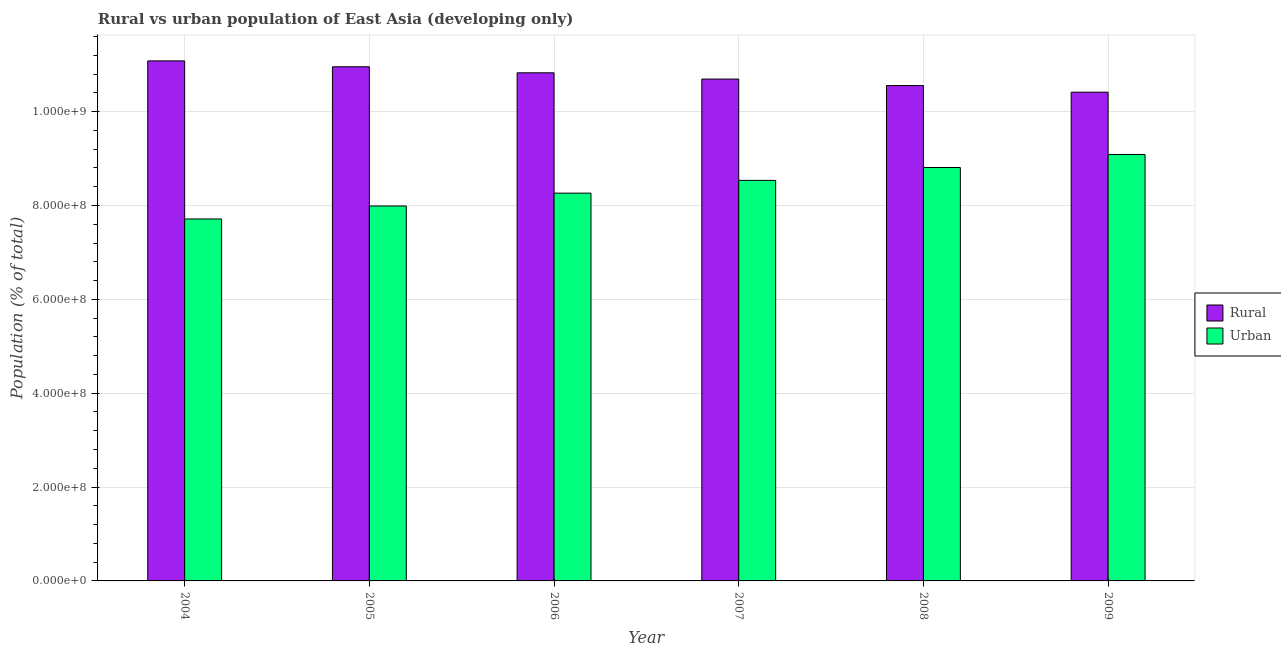How many different coloured bars are there?
Keep it short and to the point. 2. Are the number of bars on each tick of the X-axis equal?
Offer a terse response. Yes. How many bars are there on the 5th tick from the right?
Provide a short and direct response. 2. What is the label of the 6th group of bars from the left?
Offer a very short reply. 2009. In how many cases, is the number of bars for a given year not equal to the number of legend labels?
Keep it short and to the point. 0. What is the urban population density in 2008?
Offer a terse response. 8.81e+08. Across all years, what is the maximum urban population density?
Provide a succinct answer. 9.09e+08. Across all years, what is the minimum urban population density?
Your response must be concise. 7.71e+08. What is the total urban population density in the graph?
Provide a succinct answer. 5.04e+09. What is the difference between the urban population density in 2004 and that in 2006?
Offer a very short reply. -5.51e+07. What is the difference between the urban population density in 2006 and the rural population density in 2009?
Provide a short and direct response. -8.23e+07. What is the average urban population density per year?
Give a very brief answer. 8.40e+08. In the year 2009, what is the difference between the urban population density and rural population density?
Your response must be concise. 0. In how many years, is the rural population density greater than 1040000000 %?
Make the answer very short. 6. What is the ratio of the rural population density in 2005 to that in 2008?
Offer a terse response. 1.04. Is the difference between the rural population density in 2004 and 2005 greater than the difference between the urban population density in 2004 and 2005?
Make the answer very short. No. What is the difference between the highest and the second highest urban population density?
Your answer should be compact. 2.77e+07. What is the difference between the highest and the lowest urban population density?
Give a very brief answer. 1.37e+08. Is the sum of the urban population density in 2004 and 2009 greater than the maximum rural population density across all years?
Ensure brevity in your answer.  Yes. What does the 2nd bar from the left in 2006 represents?
Your answer should be compact. Urban. What does the 1st bar from the right in 2007 represents?
Offer a terse response. Urban. Are all the bars in the graph horizontal?
Your response must be concise. No. Are the values on the major ticks of Y-axis written in scientific E-notation?
Offer a terse response. Yes. What is the title of the graph?
Offer a very short reply. Rural vs urban population of East Asia (developing only). What is the label or title of the X-axis?
Provide a succinct answer. Year. What is the label or title of the Y-axis?
Your response must be concise. Population (% of total). What is the Population (% of total) in Rural in 2004?
Ensure brevity in your answer.  1.11e+09. What is the Population (% of total) of Urban in 2004?
Provide a succinct answer. 7.71e+08. What is the Population (% of total) in Rural in 2005?
Ensure brevity in your answer.  1.10e+09. What is the Population (% of total) in Urban in 2005?
Ensure brevity in your answer.  7.99e+08. What is the Population (% of total) in Rural in 2006?
Your answer should be very brief. 1.08e+09. What is the Population (% of total) in Urban in 2006?
Your answer should be compact. 8.26e+08. What is the Population (% of total) in Rural in 2007?
Keep it short and to the point. 1.07e+09. What is the Population (% of total) in Urban in 2007?
Give a very brief answer. 8.54e+08. What is the Population (% of total) of Rural in 2008?
Give a very brief answer. 1.06e+09. What is the Population (% of total) of Urban in 2008?
Provide a succinct answer. 8.81e+08. What is the Population (% of total) of Rural in 2009?
Ensure brevity in your answer.  1.04e+09. What is the Population (% of total) in Urban in 2009?
Offer a terse response. 9.09e+08. Across all years, what is the maximum Population (% of total) of Rural?
Your answer should be very brief. 1.11e+09. Across all years, what is the maximum Population (% of total) of Urban?
Make the answer very short. 9.09e+08. Across all years, what is the minimum Population (% of total) in Rural?
Your answer should be compact. 1.04e+09. Across all years, what is the minimum Population (% of total) of Urban?
Your response must be concise. 7.71e+08. What is the total Population (% of total) of Rural in the graph?
Your answer should be very brief. 6.45e+09. What is the total Population (% of total) in Urban in the graph?
Keep it short and to the point. 5.04e+09. What is the difference between the Population (% of total) in Rural in 2004 and that in 2005?
Ensure brevity in your answer.  1.26e+07. What is the difference between the Population (% of total) of Urban in 2004 and that in 2005?
Make the answer very short. -2.77e+07. What is the difference between the Population (% of total) of Rural in 2004 and that in 2006?
Offer a terse response. 2.54e+07. What is the difference between the Population (% of total) in Urban in 2004 and that in 2006?
Give a very brief answer. -5.51e+07. What is the difference between the Population (% of total) of Rural in 2004 and that in 2007?
Your answer should be compact. 3.87e+07. What is the difference between the Population (% of total) of Urban in 2004 and that in 2007?
Ensure brevity in your answer.  -8.22e+07. What is the difference between the Population (% of total) in Rural in 2004 and that in 2008?
Make the answer very short. 5.26e+07. What is the difference between the Population (% of total) in Urban in 2004 and that in 2008?
Keep it short and to the point. -1.10e+08. What is the difference between the Population (% of total) of Rural in 2004 and that in 2009?
Offer a very short reply. 6.67e+07. What is the difference between the Population (% of total) in Urban in 2004 and that in 2009?
Provide a short and direct response. -1.37e+08. What is the difference between the Population (% of total) in Rural in 2005 and that in 2006?
Ensure brevity in your answer.  1.28e+07. What is the difference between the Population (% of total) in Urban in 2005 and that in 2006?
Your answer should be very brief. -2.73e+07. What is the difference between the Population (% of total) in Rural in 2005 and that in 2007?
Ensure brevity in your answer.  2.62e+07. What is the difference between the Population (% of total) in Urban in 2005 and that in 2007?
Your answer should be very brief. -5.45e+07. What is the difference between the Population (% of total) in Rural in 2005 and that in 2008?
Offer a terse response. 4.00e+07. What is the difference between the Population (% of total) of Urban in 2005 and that in 2008?
Your answer should be very brief. -8.20e+07. What is the difference between the Population (% of total) of Rural in 2005 and that in 2009?
Provide a short and direct response. 5.42e+07. What is the difference between the Population (% of total) of Urban in 2005 and that in 2009?
Provide a succinct answer. -1.10e+08. What is the difference between the Population (% of total) in Rural in 2006 and that in 2007?
Ensure brevity in your answer.  1.33e+07. What is the difference between the Population (% of total) of Urban in 2006 and that in 2007?
Your answer should be very brief. -2.72e+07. What is the difference between the Population (% of total) in Rural in 2006 and that in 2008?
Provide a short and direct response. 2.72e+07. What is the difference between the Population (% of total) of Urban in 2006 and that in 2008?
Keep it short and to the point. -5.46e+07. What is the difference between the Population (% of total) of Rural in 2006 and that in 2009?
Your answer should be compact. 4.13e+07. What is the difference between the Population (% of total) of Urban in 2006 and that in 2009?
Offer a very short reply. -8.23e+07. What is the difference between the Population (% of total) in Rural in 2007 and that in 2008?
Offer a terse response. 1.38e+07. What is the difference between the Population (% of total) of Urban in 2007 and that in 2008?
Your answer should be very brief. -2.75e+07. What is the difference between the Population (% of total) in Rural in 2007 and that in 2009?
Keep it short and to the point. 2.80e+07. What is the difference between the Population (% of total) of Urban in 2007 and that in 2009?
Ensure brevity in your answer.  -5.52e+07. What is the difference between the Population (% of total) in Rural in 2008 and that in 2009?
Provide a succinct answer. 1.42e+07. What is the difference between the Population (% of total) in Urban in 2008 and that in 2009?
Keep it short and to the point. -2.77e+07. What is the difference between the Population (% of total) of Rural in 2004 and the Population (% of total) of Urban in 2005?
Make the answer very short. 3.09e+08. What is the difference between the Population (% of total) in Rural in 2004 and the Population (% of total) in Urban in 2006?
Provide a succinct answer. 2.82e+08. What is the difference between the Population (% of total) of Rural in 2004 and the Population (% of total) of Urban in 2007?
Provide a succinct answer. 2.55e+08. What is the difference between the Population (% of total) of Rural in 2004 and the Population (% of total) of Urban in 2008?
Give a very brief answer. 2.27e+08. What is the difference between the Population (% of total) in Rural in 2004 and the Population (% of total) in Urban in 2009?
Your answer should be compact. 2.00e+08. What is the difference between the Population (% of total) of Rural in 2005 and the Population (% of total) of Urban in 2006?
Your answer should be compact. 2.69e+08. What is the difference between the Population (% of total) in Rural in 2005 and the Population (% of total) in Urban in 2007?
Offer a very short reply. 2.42e+08. What is the difference between the Population (% of total) of Rural in 2005 and the Population (% of total) of Urban in 2008?
Provide a succinct answer. 2.15e+08. What is the difference between the Population (% of total) in Rural in 2005 and the Population (% of total) in Urban in 2009?
Your answer should be very brief. 1.87e+08. What is the difference between the Population (% of total) in Rural in 2006 and the Population (% of total) in Urban in 2007?
Ensure brevity in your answer.  2.29e+08. What is the difference between the Population (% of total) in Rural in 2006 and the Population (% of total) in Urban in 2008?
Your answer should be compact. 2.02e+08. What is the difference between the Population (% of total) in Rural in 2006 and the Population (% of total) in Urban in 2009?
Provide a short and direct response. 1.74e+08. What is the difference between the Population (% of total) of Rural in 2007 and the Population (% of total) of Urban in 2008?
Keep it short and to the point. 1.88e+08. What is the difference between the Population (% of total) in Rural in 2007 and the Population (% of total) in Urban in 2009?
Offer a terse response. 1.61e+08. What is the difference between the Population (% of total) in Rural in 2008 and the Population (% of total) in Urban in 2009?
Provide a succinct answer. 1.47e+08. What is the average Population (% of total) of Rural per year?
Keep it short and to the point. 1.08e+09. What is the average Population (% of total) of Urban per year?
Make the answer very short. 8.40e+08. In the year 2004, what is the difference between the Population (% of total) of Rural and Population (% of total) of Urban?
Your answer should be compact. 3.37e+08. In the year 2005, what is the difference between the Population (% of total) in Rural and Population (% of total) in Urban?
Provide a short and direct response. 2.97e+08. In the year 2006, what is the difference between the Population (% of total) of Rural and Population (% of total) of Urban?
Offer a terse response. 2.56e+08. In the year 2007, what is the difference between the Population (% of total) of Rural and Population (% of total) of Urban?
Your answer should be very brief. 2.16e+08. In the year 2008, what is the difference between the Population (% of total) of Rural and Population (% of total) of Urban?
Provide a succinct answer. 1.75e+08. In the year 2009, what is the difference between the Population (% of total) in Rural and Population (% of total) in Urban?
Give a very brief answer. 1.33e+08. What is the ratio of the Population (% of total) of Rural in 2004 to that in 2005?
Provide a short and direct response. 1.01. What is the ratio of the Population (% of total) of Urban in 2004 to that in 2005?
Your answer should be very brief. 0.97. What is the ratio of the Population (% of total) in Rural in 2004 to that in 2006?
Keep it short and to the point. 1.02. What is the ratio of the Population (% of total) in Urban in 2004 to that in 2006?
Offer a terse response. 0.93. What is the ratio of the Population (% of total) of Rural in 2004 to that in 2007?
Keep it short and to the point. 1.04. What is the ratio of the Population (% of total) in Urban in 2004 to that in 2007?
Ensure brevity in your answer.  0.9. What is the ratio of the Population (% of total) of Rural in 2004 to that in 2008?
Offer a terse response. 1.05. What is the ratio of the Population (% of total) of Urban in 2004 to that in 2008?
Offer a very short reply. 0.88. What is the ratio of the Population (% of total) of Rural in 2004 to that in 2009?
Your answer should be compact. 1.06. What is the ratio of the Population (% of total) of Urban in 2004 to that in 2009?
Provide a succinct answer. 0.85. What is the ratio of the Population (% of total) in Rural in 2005 to that in 2006?
Make the answer very short. 1.01. What is the ratio of the Population (% of total) of Urban in 2005 to that in 2006?
Your response must be concise. 0.97. What is the ratio of the Population (% of total) in Rural in 2005 to that in 2007?
Keep it short and to the point. 1.02. What is the ratio of the Population (% of total) in Urban in 2005 to that in 2007?
Make the answer very short. 0.94. What is the ratio of the Population (% of total) of Rural in 2005 to that in 2008?
Provide a short and direct response. 1.04. What is the ratio of the Population (% of total) in Urban in 2005 to that in 2008?
Your answer should be compact. 0.91. What is the ratio of the Population (% of total) in Rural in 2005 to that in 2009?
Provide a succinct answer. 1.05. What is the ratio of the Population (% of total) of Urban in 2005 to that in 2009?
Your answer should be compact. 0.88. What is the ratio of the Population (% of total) of Rural in 2006 to that in 2007?
Make the answer very short. 1.01. What is the ratio of the Population (% of total) of Urban in 2006 to that in 2007?
Ensure brevity in your answer.  0.97. What is the ratio of the Population (% of total) of Rural in 2006 to that in 2008?
Provide a short and direct response. 1.03. What is the ratio of the Population (% of total) of Urban in 2006 to that in 2008?
Provide a short and direct response. 0.94. What is the ratio of the Population (% of total) of Rural in 2006 to that in 2009?
Keep it short and to the point. 1.04. What is the ratio of the Population (% of total) of Urban in 2006 to that in 2009?
Offer a very short reply. 0.91. What is the ratio of the Population (% of total) of Rural in 2007 to that in 2008?
Offer a very short reply. 1.01. What is the ratio of the Population (% of total) in Urban in 2007 to that in 2008?
Provide a short and direct response. 0.97. What is the ratio of the Population (% of total) in Rural in 2007 to that in 2009?
Ensure brevity in your answer.  1.03. What is the ratio of the Population (% of total) of Urban in 2007 to that in 2009?
Your answer should be very brief. 0.94. What is the ratio of the Population (% of total) in Rural in 2008 to that in 2009?
Offer a very short reply. 1.01. What is the ratio of the Population (% of total) in Urban in 2008 to that in 2009?
Your answer should be very brief. 0.97. What is the difference between the highest and the second highest Population (% of total) in Rural?
Your answer should be very brief. 1.26e+07. What is the difference between the highest and the second highest Population (% of total) in Urban?
Your answer should be compact. 2.77e+07. What is the difference between the highest and the lowest Population (% of total) in Rural?
Your answer should be very brief. 6.67e+07. What is the difference between the highest and the lowest Population (% of total) of Urban?
Keep it short and to the point. 1.37e+08. 